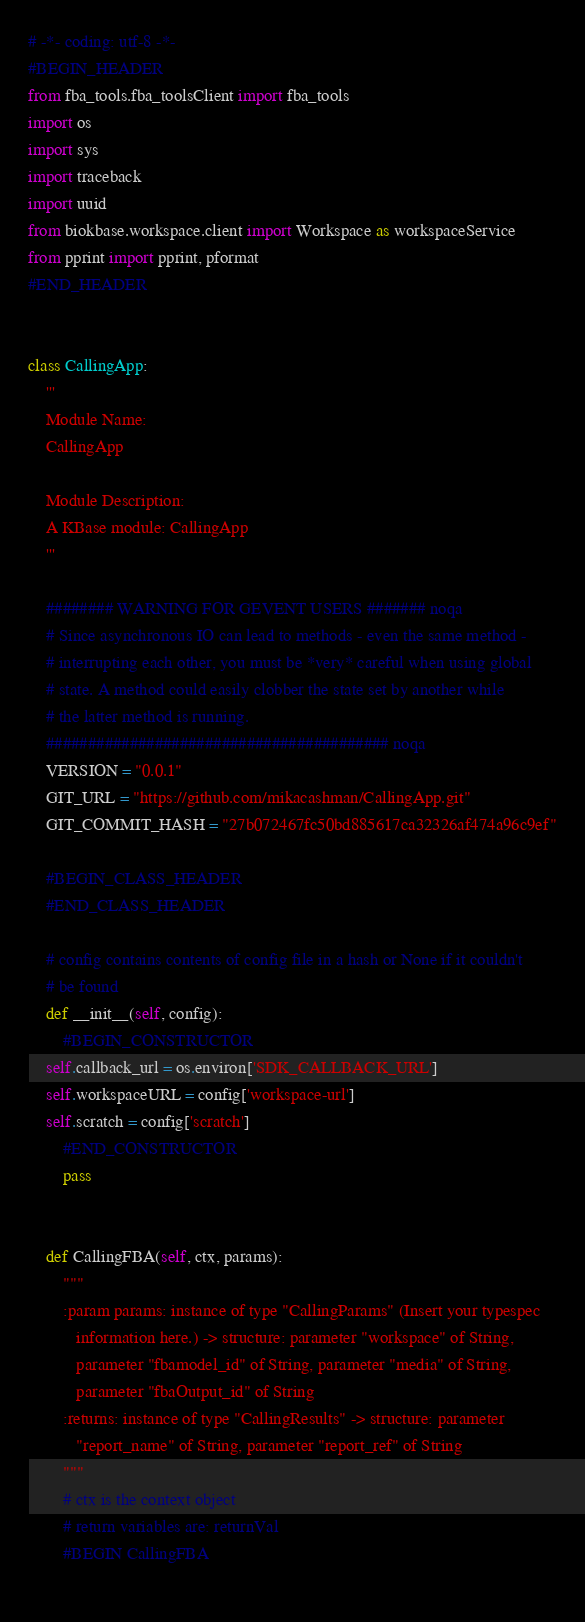Convert code to text. <code><loc_0><loc_0><loc_500><loc_500><_Python_># -*- coding: utf-8 -*-
#BEGIN_HEADER
from fba_tools.fba_toolsClient import fba_tools
import os
import sys
import traceback
import uuid
from biokbase.workspace.client import Workspace as workspaceService
from pprint import pprint, pformat
#END_HEADER


class CallingApp:
    '''
    Module Name:
    CallingApp

    Module Description:
    A KBase module: CallingApp
    '''

    ######## WARNING FOR GEVENT USERS ####### noqa
    # Since asynchronous IO can lead to methods - even the same method -
    # interrupting each other, you must be *very* careful when using global
    # state. A method could easily clobber the state set by another while
    # the latter method is running.
    ######################################### noqa
    VERSION = "0.0.1"
    GIT_URL = "https://github.com/mikacashman/CallingApp.git"
    GIT_COMMIT_HASH = "27b072467fc50bd885617ca32326af474a96c9ef"

    #BEGIN_CLASS_HEADER
    #END_CLASS_HEADER

    # config contains contents of config file in a hash or None if it couldn't
    # be found
    def __init__(self, config):
        #BEGIN_CONSTRUCTOR
	self.callback_url = os.environ['SDK_CALLBACK_URL']
	self.workspaceURL = config['workspace-url']
	self.scratch = config['scratch']
        #END_CONSTRUCTOR
        pass


    def CallingFBA(self, ctx, params):
        """
        :param params: instance of type "CallingParams" (Insert your typespec
           information here.) -> structure: parameter "workspace" of String,
           parameter "fbamodel_id" of String, parameter "media" of String,
           parameter "fbaOutput_id" of String
        :returns: instance of type "CallingResults" -> structure: parameter
           "report_name" of String, parameter "report_ref" of String
        """
        # ctx is the context object
        # return variables are: returnVal
        #BEGIN CallingFBA
	</code> 